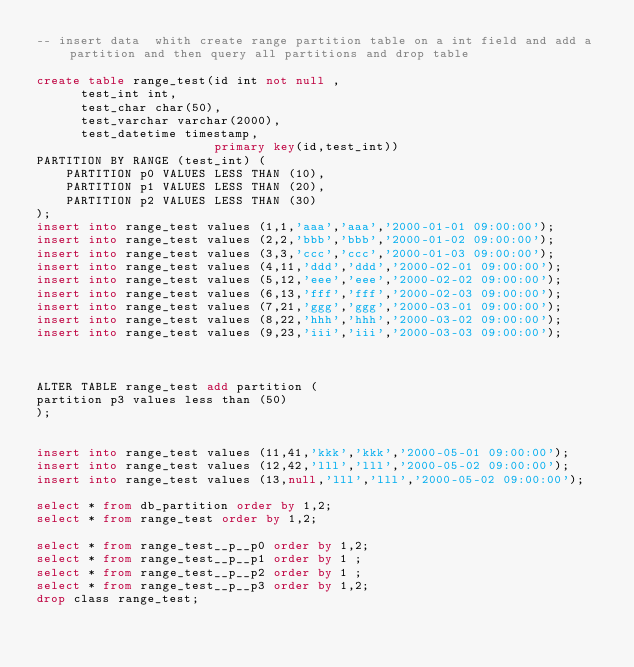<code> <loc_0><loc_0><loc_500><loc_500><_SQL_>-- insert data  whith create range partition table on a int field and add a partition and then query all partitions and drop table

create table range_test(id int not null ,
			test_int int,
			test_char char(50),
			test_varchar varchar(2000),
			test_datetime timestamp,
                        primary key(id,test_int))
PARTITION BY RANGE (test_int) (
    PARTITION p0 VALUES LESS THAN (10),
    PARTITION p1 VALUES LESS THAN (20),
    PARTITION p2 VALUES LESS THAN (30)
);
insert into range_test values (1,1,'aaa','aaa','2000-01-01 09:00:00');
insert into range_test values (2,2,'bbb','bbb','2000-01-02 09:00:00');
insert into range_test values (3,3,'ccc','ccc','2000-01-03 09:00:00');
insert into range_test values (4,11,'ddd','ddd','2000-02-01 09:00:00');
insert into range_test values (5,12,'eee','eee','2000-02-02 09:00:00');
insert into range_test values (6,13,'fff','fff','2000-02-03 09:00:00');
insert into range_test values (7,21,'ggg','ggg','2000-03-01 09:00:00');
insert into range_test values (8,22,'hhh','hhh','2000-03-02 09:00:00');
insert into range_test values (9,23,'iii','iii','2000-03-03 09:00:00');



ALTER TABLE range_test add partition (
partition p3 values less than (50)
);


insert into range_test values (11,41,'kkk','kkk','2000-05-01 09:00:00');
insert into range_test values (12,42,'lll','lll','2000-05-02 09:00:00');
insert into range_test values (13,null,'lll','lll','2000-05-02 09:00:00');

select * from db_partition order by 1,2;
select * from range_test order by 1,2;

select * from range_test__p__p0 order by 1,2;
select * from range_test__p__p1 order by 1 ;
select * from range_test__p__p2 order by 1 ;
select * from range_test__p__p3 order by 1,2;
drop class range_test;
</code> 